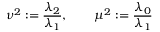<formula> <loc_0><loc_0><loc_500><loc_500>\nu ^ { 2 } \colon = \frac { \lambda _ { 2 } } { \lambda _ { 1 } } , \quad \mu ^ { 2 } \colon = \frac { \lambda _ { 0 } } { \lambda _ { 1 } }</formula> 